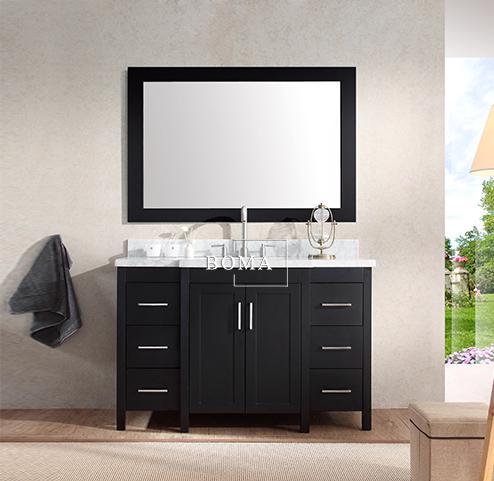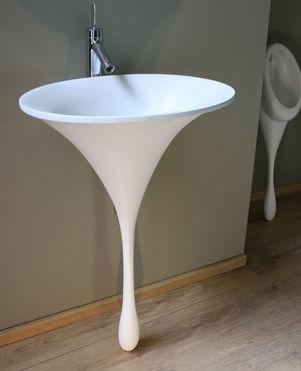The first image is the image on the left, the second image is the image on the right. Examine the images to the left and right. Is the description "In one image there is a sink with a very narrow pedestal in the center of the image." accurate? Answer yes or no. Yes. 